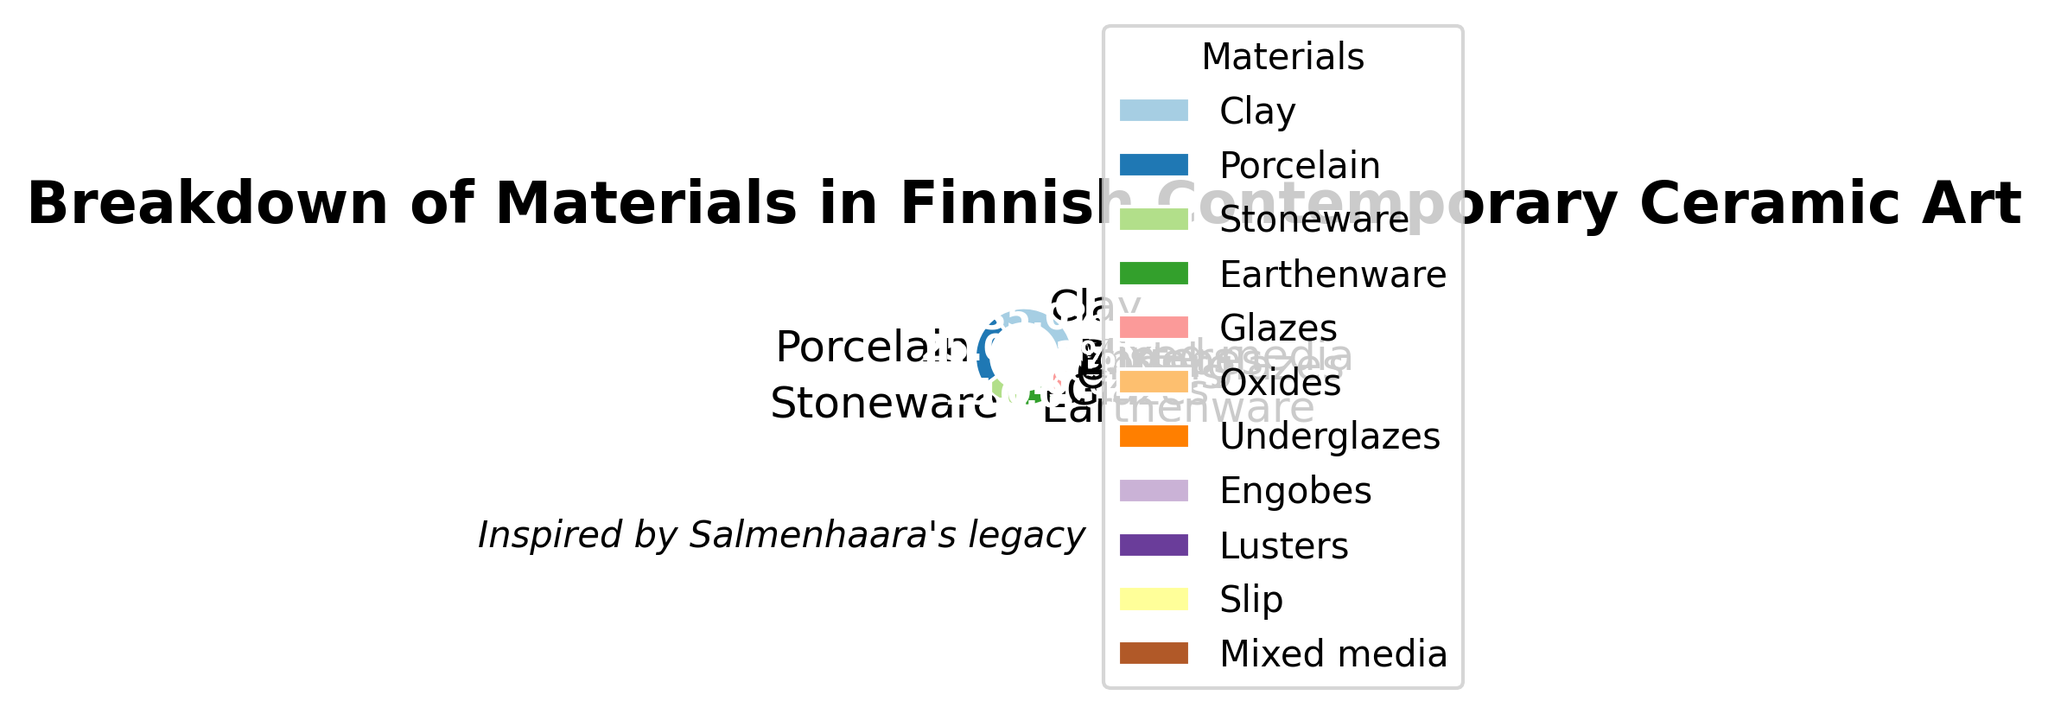What's the most used material in Finnish contemporary ceramic art? To find the most used material, look for the material with the largest percentage on the pie chart. The segment labeled "Clay" represents the largest slice, indicating 35%.
Answer: Clay Which material is used least frequently and what is its percentage? Identify the smallest segment on the pie chart; the label is "Mixed media" with a percentage of 0.2%.
Answer: Mixed media, 0.2% What is the combined percentage of Stoneware and Earthenware? Locate the percentages for Stoneware (15%) and Earthenware (10%), then add them together: 15% + 10% = 25%.
Answer: 25% How much more prevalent is Porcelain compared to Glazes? Find the percentages for Porcelain (25%) and Glazes (8%). Subtract the percentage of Glazes from Porcelain: 25% - 8% = 17%.
Answer: 17% What materials occupy the smallest and largest parts of the pie chart, respectively? The smallest segment is "Mixed media" at 0.2%, and the largest segment is "Clay" at 35%.
Answer: Mixed media and Clay What is the color of the segment representing Earthenware? Visually identify the color of the Earthenware segment; it appears to be light blue.
Answer: Light blue If you combine the percentages of all Oxides, Underglazes, and Engobes, what is the total? Sum the percentages of Oxides (3%), Underglazes (2%), and Engobes (1%): 3% + 2% + 1% = 6%.
Answer: 6% What would be the average percentage use of Glazes, Oxides, and Lusters? Find their individual percentages: Glazes (8%), Oxides (3%), Lusters (0.5%). Calculate the average: (8 + 3 + 0.5) / 3 = 3.83% (rounded to two decimal places).
Answer: 3.83% Are there more materials with a percentage above 10% or below 5%? Count materials above 10%: Clay (35%), Porcelain (25%), Stoneware (15%), Earthenware (10%) — 4 materials. Count materials below 5%: Oxides (3%), Underglazes (2%), Engobes (1%), Lusters (0.5%), Slip (0.3%), Mixed media (0.2%) — 6 materials.
Answer: Below 5% Which material is exactly in the middle when sorted by percentage? Sort the percentages: 35, 25, 15, 10, 8, 3, 2, 1, 0.5, 0.3, 0.2. The middle value in this sorted list is 8%, corresponding to Glazes.
Answer: Glazes 